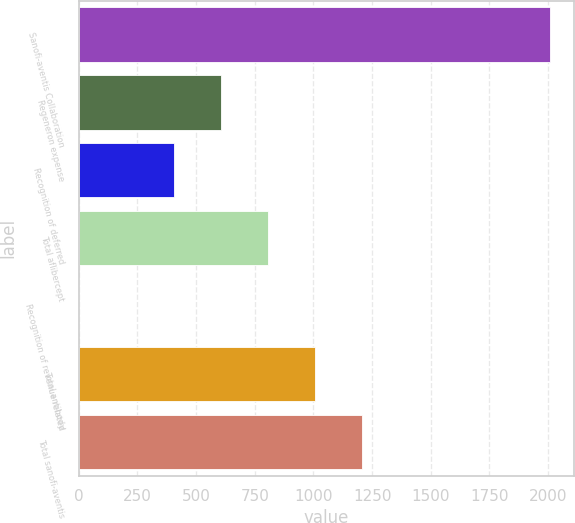Convert chart. <chart><loc_0><loc_0><loc_500><loc_500><bar_chart><fcel>Sanofi-aventis Collaboration<fcel>Regeneron expense<fcel>Recognition of deferred<fcel>Total aflibercept<fcel>Recognition of revenue related<fcel>Total antibody<fcel>Total sanofi-aventis<nl><fcel>2009<fcel>604.59<fcel>403.96<fcel>805.22<fcel>2.7<fcel>1005.85<fcel>1206.48<nl></chart> 